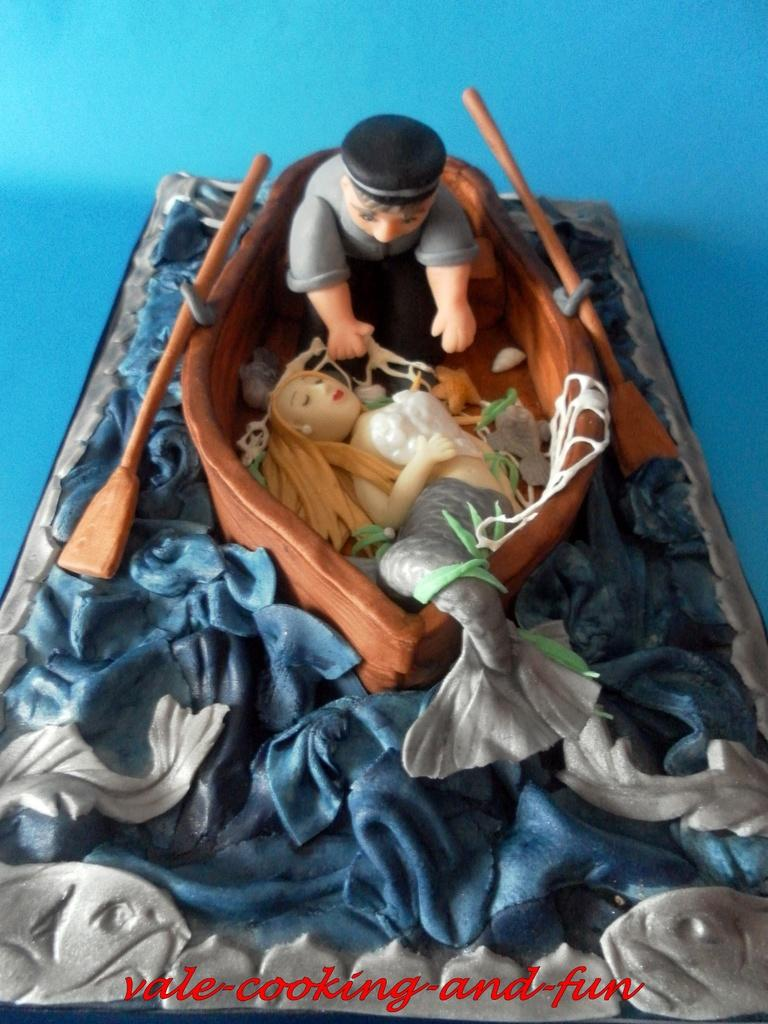What is the main subject of the image? The main subject of the image is a toy. What can be observed about the design of the toy? There are rows in the toy. What type of vehicle is present in the toy? There is a boat in the toy. Are there any mythical creatures in the toy? Yes, there is a mermaid in the toy. Are there any human figures in the toy? Yes, there is a man in the toy. What type of robin can be seen interacting with the man in the toy? There is no robin present in the toy; it features a boat, a mermaid, and a man. 